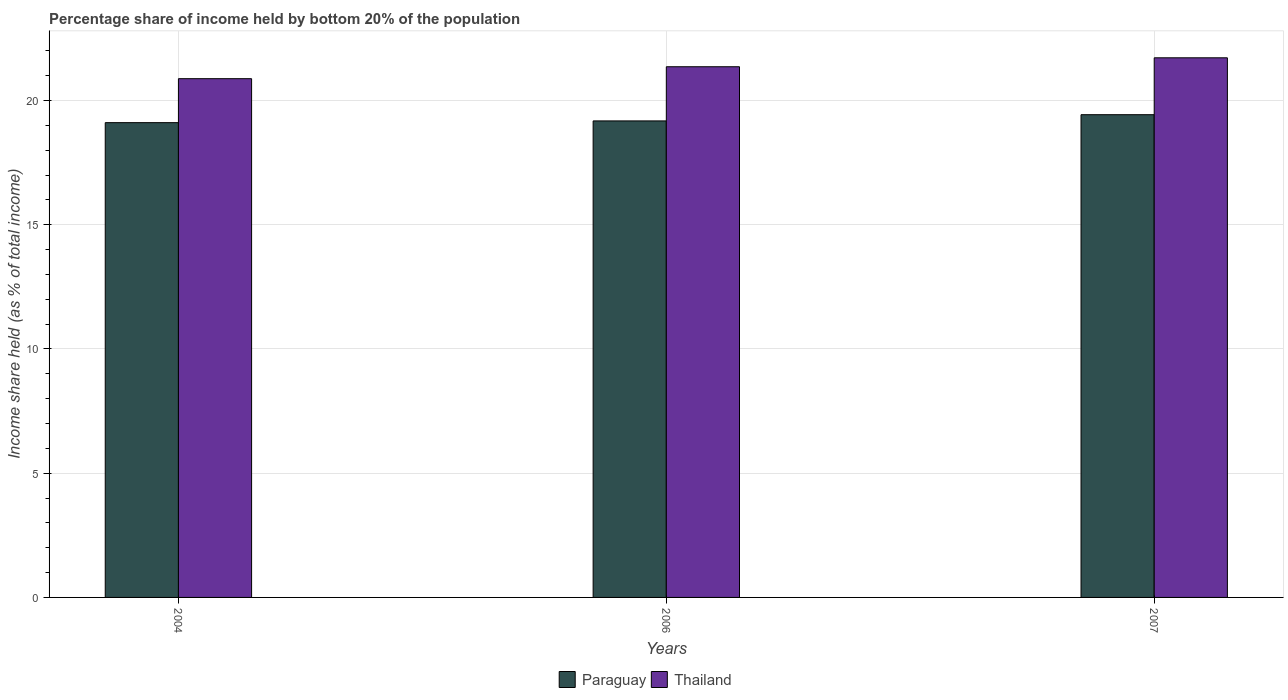How many groups of bars are there?
Provide a short and direct response. 3. Are the number of bars on each tick of the X-axis equal?
Your answer should be very brief. Yes. How many bars are there on the 2nd tick from the left?
Keep it short and to the point. 2. How many bars are there on the 2nd tick from the right?
Make the answer very short. 2. What is the label of the 3rd group of bars from the left?
Provide a short and direct response. 2007. In how many cases, is the number of bars for a given year not equal to the number of legend labels?
Offer a very short reply. 0. What is the share of income held by bottom 20% of the population in Paraguay in 2004?
Offer a very short reply. 19.11. Across all years, what is the maximum share of income held by bottom 20% of the population in Paraguay?
Make the answer very short. 19.43. Across all years, what is the minimum share of income held by bottom 20% of the population in Paraguay?
Offer a very short reply. 19.11. In which year was the share of income held by bottom 20% of the population in Thailand maximum?
Ensure brevity in your answer.  2007. What is the total share of income held by bottom 20% of the population in Paraguay in the graph?
Offer a terse response. 57.72. What is the difference between the share of income held by bottom 20% of the population in Thailand in 2006 and that in 2007?
Provide a succinct answer. -0.36. What is the difference between the share of income held by bottom 20% of the population in Paraguay in 2006 and the share of income held by bottom 20% of the population in Thailand in 2004?
Provide a succinct answer. -1.7. What is the average share of income held by bottom 20% of the population in Thailand per year?
Your response must be concise. 21.32. In the year 2007, what is the difference between the share of income held by bottom 20% of the population in Thailand and share of income held by bottom 20% of the population in Paraguay?
Your response must be concise. 2.29. What is the ratio of the share of income held by bottom 20% of the population in Thailand in 2004 to that in 2007?
Provide a succinct answer. 0.96. Is the share of income held by bottom 20% of the population in Paraguay in 2004 less than that in 2007?
Ensure brevity in your answer.  Yes. What is the difference between the highest and the second highest share of income held by bottom 20% of the population in Thailand?
Your answer should be compact. 0.36. What is the difference between the highest and the lowest share of income held by bottom 20% of the population in Paraguay?
Your answer should be very brief. 0.32. In how many years, is the share of income held by bottom 20% of the population in Paraguay greater than the average share of income held by bottom 20% of the population in Paraguay taken over all years?
Offer a terse response. 1. What does the 2nd bar from the left in 2007 represents?
Your answer should be very brief. Thailand. What does the 1st bar from the right in 2007 represents?
Keep it short and to the point. Thailand. How many bars are there?
Your answer should be very brief. 6. Does the graph contain any zero values?
Your answer should be very brief. No. Does the graph contain grids?
Provide a short and direct response. Yes. How many legend labels are there?
Your answer should be very brief. 2. How are the legend labels stacked?
Provide a succinct answer. Horizontal. What is the title of the graph?
Ensure brevity in your answer.  Percentage share of income held by bottom 20% of the population. Does "Mauritius" appear as one of the legend labels in the graph?
Offer a terse response. No. What is the label or title of the Y-axis?
Your answer should be compact. Income share held (as % of total income). What is the Income share held (as % of total income) in Paraguay in 2004?
Offer a very short reply. 19.11. What is the Income share held (as % of total income) of Thailand in 2004?
Ensure brevity in your answer.  20.88. What is the Income share held (as % of total income) of Paraguay in 2006?
Your answer should be compact. 19.18. What is the Income share held (as % of total income) of Thailand in 2006?
Your answer should be very brief. 21.36. What is the Income share held (as % of total income) of Paraguay in 2007?
Offer a very short reply. 19.43. What is the Income share held (as % of total income) of Thailand in 2007?
Offer a very short reply. 21.72. Across all years, what is the maximum Income share held (as % of total income) in Paraguay?
Your answer should be very brief. 19.43. Across all years, what is the maximum Income share held (as % of total income) in Thailand?
Make the answer very short. 21.72. Across all years, what is the minimum Income share held (as % of total income) in Paraguay?
Your answer should be compact. 19.11. Across all years, what is the minimum Income share held (as % of total income) of Thailand?
Provide a short and direct response. 20.88. What is the total Income share held (as % of total income) in Paraguay in the graph?
Offer a very short reply. 57.72. What is the total Income share held (as % of total income) of Thailand in the graph?
Give a very brief answer. 63.96. What is the difference between the Income share held (as % of total income) in Paraguay in 2004 and that in 2006?
Give a very brief answer. -0.07. What is the difference between the Income share held (as % of total income) of Thailand in 2004 and that in 2006?
Your answer should be compact. -0.48. What is the difference between the Income share held (as % of total income) of Paraguay in 2004 and that in 2007?
Make the answer very short. -0.32. What is the difference between the Income share held (as % of total income) of Thailand in 2004 and that in 2007?
Provide a short and direct response. -0.84. What is the difference between the Income share held (as % of total income) of Thailand in 2006 and that in 2007?
Your answer should be very brief. -0.36. What is the difference between the Income share held (as % of total income) in Paraguay in 2004 and the Income share held (as % of total income) in Thailand in 2006?
Give a very brief answer. -2.25. What is the difference between the Income share held (as % of total income) of Paraguay in 2004 and the Income share held (as % of total income) of Thailand in 2007?
Your response must be concise. -2.61. What is the difference between the Income share held (as % of total income) in Paraguay in 2006 and the Income share held (as % of total income) in Thailand in 2007?
Keep it short and to the point. -2.54. What is the average Income share held (as % of total income) in Paraguay per year?
Ensure brevity in your answer.  19.24. What is the average Income share held (as % of total income) in Thailand per year?
Provide a succinct answer. 21.32. In the year 2004, what is the difference between the Income share held (as % of total income) of Paraguay and Income share held (as % of total income) of Thailand?
Provide a succinct answer. -1.77. In the year 2006, what is the difference between the Income share held (as % of total income) of Paraguay and Income share held (as % of total income) of Thailand?
Make the answer very short. -2.18. In the year 2007, what is the difference between the Income share held (as % of total income) in Paraguay and Income share held (as % of total income) in Thailand?
Your response must be concise. -2.29. What is the ratio of the Income share held (as % of total income) in Thailand in 2004 to that in 2006?
Offer a very short reply. 0.98. What is the ratio of the Income share held (as % of total income) of Paraguay in 2004 to that in 2007?
Provide a short and direct response. 0.98. What is the ratio of the Income share held (as % of total income) of Thailand in 2004 to that in 2007?
Provide a succinct answer. 0.96. What is the ratio of the Income share held (as % of total income) in Paraguay in 2006 to that in 2007?
Ensure brevity in your answer.  0.99. What is the ratio of the Income share held (as % of total income) in Thailand in 2006 to that in 2007?
Provide a short and direct response. 0.98. What is the difference between the highest and the second highest Income share held (as % of total income) of Thailand?
Your response must be concise. 0.36. What is the difference between the highest and the lowest Income share held (as % of total income) of Paraguay?
Your answer should be compact. 0.32. What is the difference between the highest and the lowest Income share held (as % of total income) of Thailand?
Offer a very short reply. 0.84. 